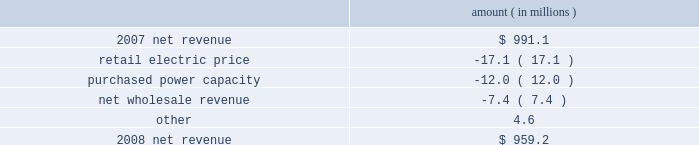Entergy louisiana , llc management's financial discussion and analysis net revenue 2008 compared to 2007 net revenue consists of operating revenues net of : 1 ) fuel , fuel-related expenses , and gas purchased for resale , 2 ) purchased power expenses , and 3 ) other regulatory charges .
Following is an analysis of the change in net revenue comparing 2008 to 2007 .
Amount ( in millions ) .
The retail electric price variance is primarily due to the cessation of the interim storm recovery through the formula rate plan upon the act 55 financing of storm costs and a credit passed on to customers as a result of the act 55 storm cost financing , partially offset by increases in the formula rate plan effective october 2007 .
Refer to "hurricane rita and hurricane katrina" and "state and local rate regulation" below for a discussion of the interim recovery of storm costs , the act 55 storm cost financing , and the formula rate plan filing .
The purchased power capacity variance is due to the amortization of deferred capacity costs effective september 2007 as a result of the formula rate plan filing in may 2007 .
Purchased power capacity costs are offset in base revenues due to a base rate increase implemented to recover incremental deferred and ongoing purchased power capacity charges .
See "state and local rate regulation" below for a discussion of the formula rate plan filing .
The net wholesale revenue variance is primarily due to provisions recorded for potential rate refunds related to the treatment of interruptible load in pricing entergy system affiliate sales .
Gross operating revenue and , fuel and purchased power expenses gross operating revenues increased primarily due to an increase of $ 364.7 million in fuel cost recovery revenues due to higher fuel rates offset by decreased usage .
The increase was partially offset by a decrease of $ 56.8 million in gross wholesale revenue due to a decrease in system agreement rough production cost equalization credits .
Fuel and purchased power expenses increased primarily due to increases in the average market prices of natural gas and purchased power , partially offset by a decrease in the recovery from customers of deferred fuel costs. .
What is the percent change in net revenue between 2007 and 2008? 
Computations: ((959.2 - 991.1) / 991.1)
Answer: -0.03219. 